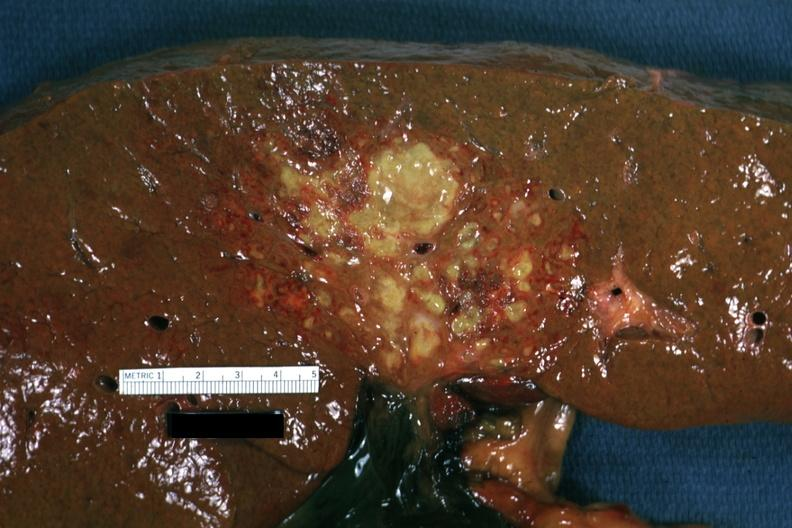does this look like an ascending cholangitis?
Answer the question using a single word or phrase. Yes 